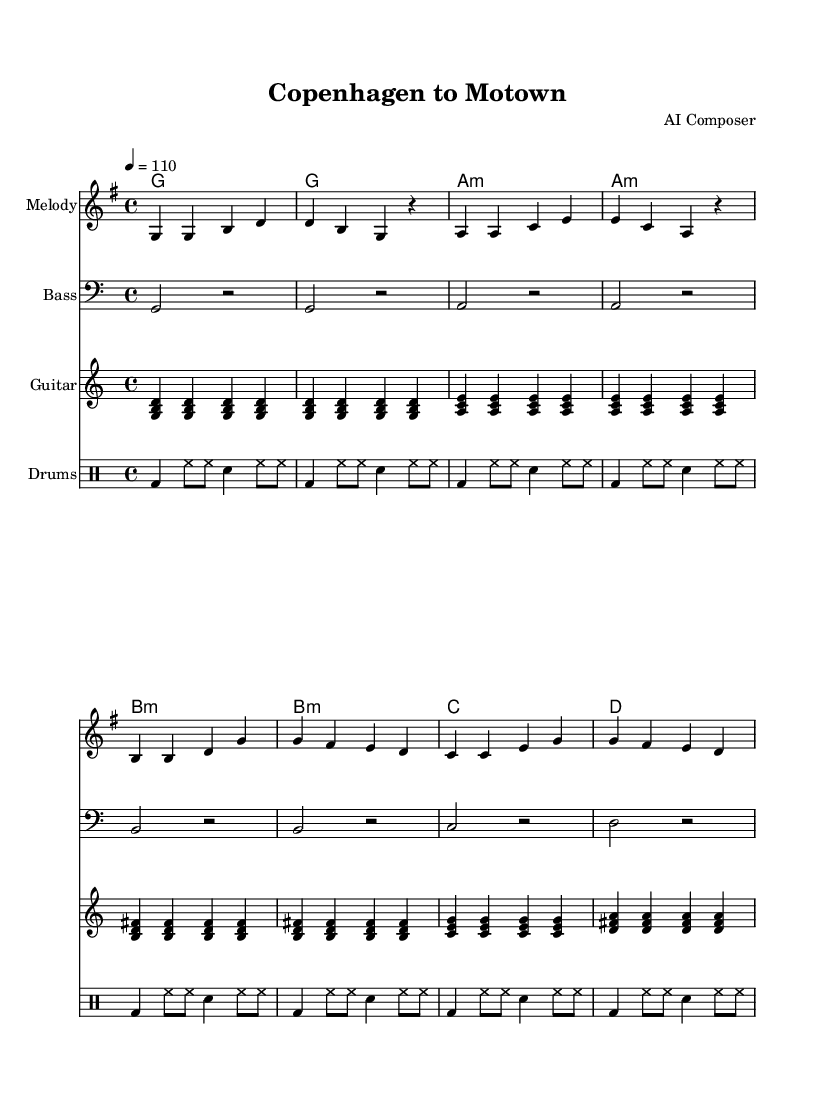What is the key signature of this music? The key signature is G major, which has one sharp (F#). This is indicated by the "g" at the beginning of the staff, which shows that the key signature is based on G.
Answer: G major What is the time signature of this music? The time signature is 4/4, which means there are four beats in each measure and the quarter note gets the beat. This is indicated at the beginning of the score by the notation "4/4".
Answer: 4/4 What is the tempo marking of the piece? The tempo marking is 110 BPM, indicated by "4 = 110", meaning that the quarter note is played at a speed of 110 beats per minute.
Answer: 110 How many measures are there in the melody? The melody consists of eight measures, as seen on the staff where each distinct grouping of notes separated by vertical lines represents one measure.
Answer: 8 What harmony is used in the first measure? The first measure features a G major chord, represented in the chord brackets at the beginning of the score with "g". This chord consists of the notes G, B, and D.
Answer: G major How many different chords are used in the harmonies? There are five different chords used in the harmonies: G major, A minor, B minor, C major, and D major. Each distinct chord is indicated in the chord names section of the score, showcasing varied harmonic progression.
Answer: 5 What type of rhythm is primarily used for the drums? The drums use a standard backbeat rhythm, which consists of bass drum hits on beats 1 and 3 and snare hits on beats 2 and 4, creating a groove common in Rhythm and Blues music.
Answer: Backbeat 